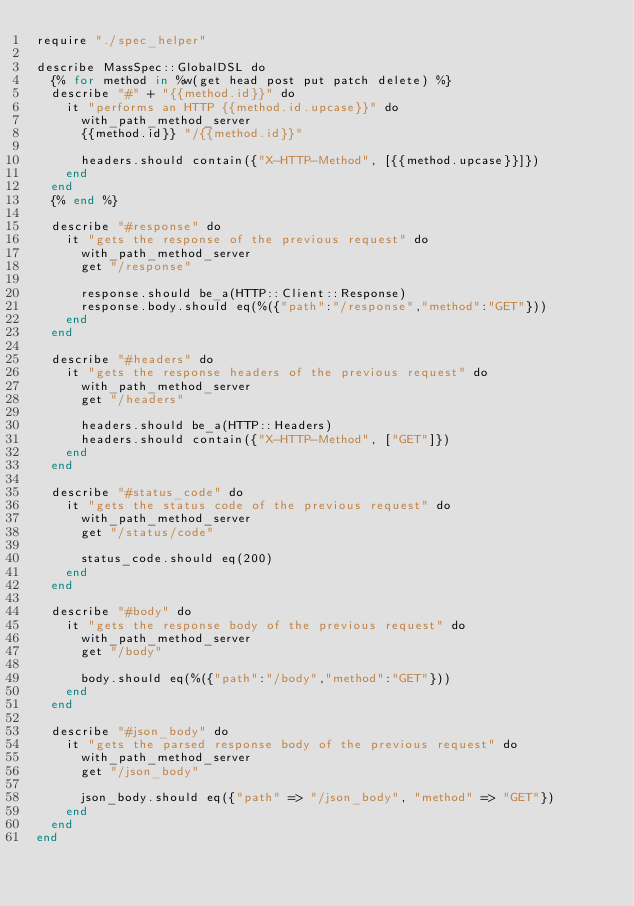Convert code to text. <code><loc_0><loc_0><loc_500><loc_500><_Crystal_>require "./spec_helper"

describe MassSpec::GlobalDSL do
  {% for method in %w(get head post put patch delete) %}
  describe "#" + "{{method.id}}" do
    it "performs an HTTP {{method.id.upcase}}" do
      with_path_method_server
      {{method.id}} "/{{method.id}}"

      headers.should contain({"X-HTTP-Method", [{{method.upcase}}]})
    end
  end
  {% end %}

  describe "#response" do
    it "gets the response of the previous request" do
      with_path_method_server
      get "/response"

      response.should be_a(HTTP::Client::Response)
      response.body.should eq(%({"path":"/response","method":"GET"}))
    end
  end

  describe "#headers" do
    it "gets the response headers of the previous request" do
      with_path_method_server
      get "/headers"

      headers.should be_a(HTTP::Headers)
      headers.should contain({"X-HTTP-Method", ["GET"]})
    end
  end

  describe "#status_code" do
    it "gets the status code of the previous request" do
      with_path_method_server
      get "/status/code"

      status_code.should eq(200)
    end
  end

  describe "#body" do
    it "gets the response body of the previous request" do
      with_path_method_server
      get "/body"

      body.should eq(%({"path":"/body","method":"GET"}))
    end
  end

  describe "#json_body" do
    it "gets the parsed response body of the previous request" do
      with_path_method_server
      get "/json_body"

      json_body.should eq({"path" => "/json_body", "method" => "GET"})
    end
  end
end
</code> 